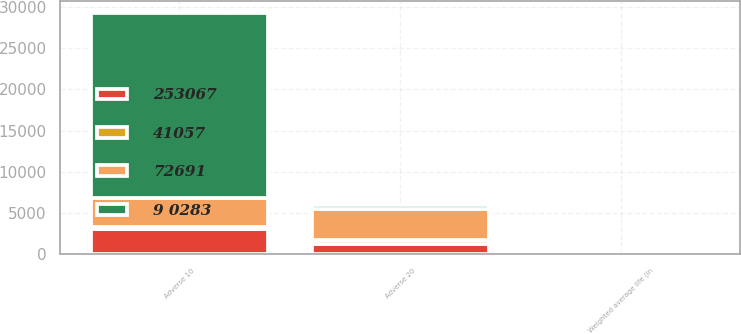Convert chart. <chart><loc_0><loc_0><loc_500><loc_500><stacked_bar_chart><ecel><fcel>Weighted average life (in<fcel>Adverse 10<fcel>Adverse 20<nl><fcel>253067<fcel>5.7<fcel>3067<fcel>1186<nl><fcel>41057<fcel>2.4<fcel>263<fcel>545<nl><fcel>72691<fcel>4.1<fcel>3517<fcel>3735<nl><fcel>9 0283<fcel>1.4<fcel>22410<fcel>545<nl></chart> 